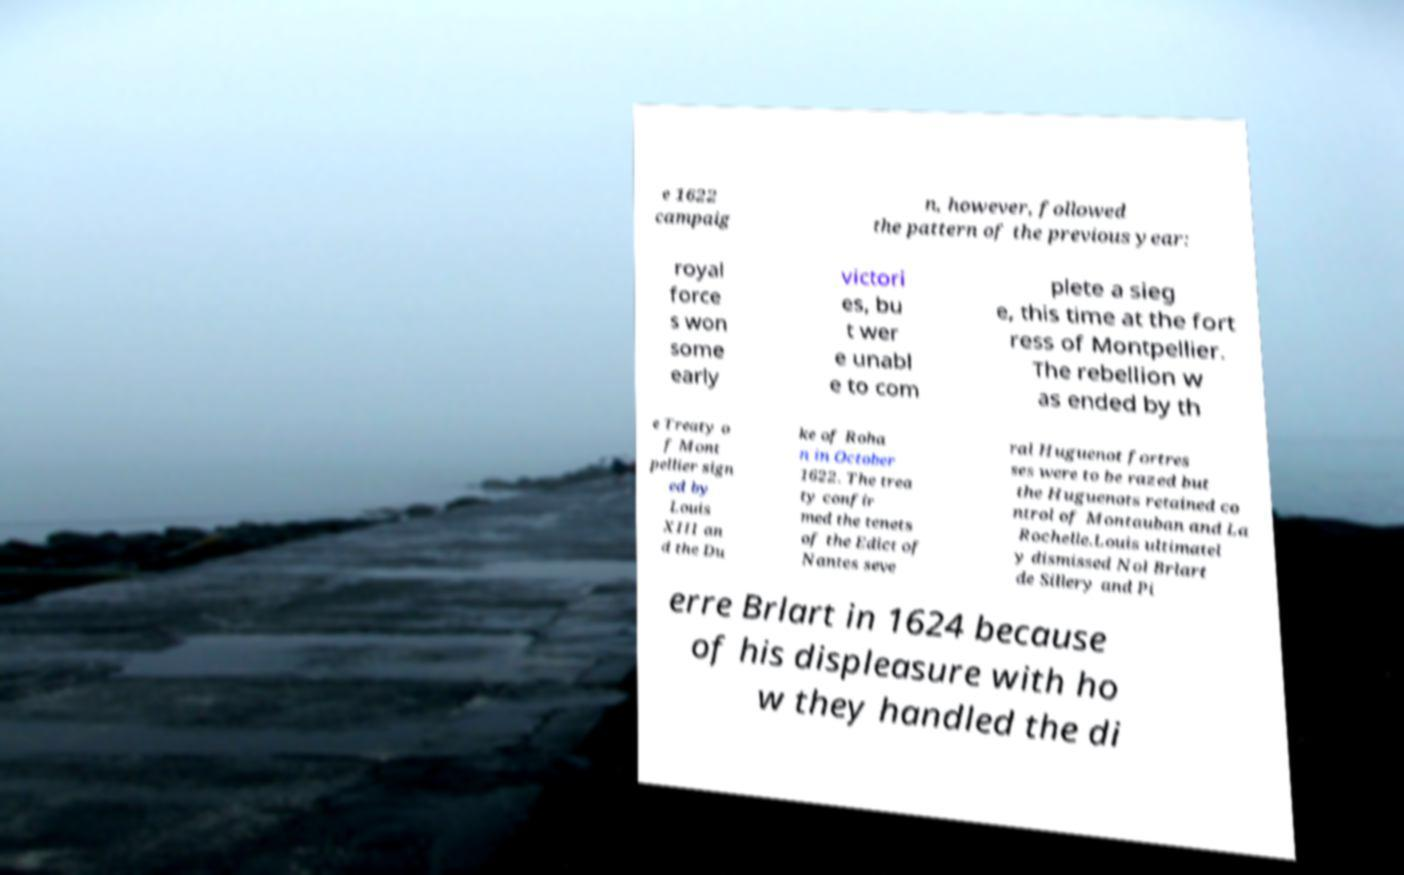I need the written content from this picture converted into text. Can you do that? e 1622 campaig n, however, followed the pattern of the previous year: royal force s won some early victori es, bu t wer e unabl e to com plete a sieg e, this time at the fort ress of Montpellier. The rebellion w as ended by th e Treaty o f Mont pellier sign ed by Louis XIII an d the Du ke of Roha n in October 1622. The trea ty confir med the tenets of the Edict of Nantes seve ral Huguenot fortres ses were to be razed but the Huguenots retained co ntrol of Montauban and La Rochelle.Louis ultimatel y dismissed Nol Brlart de Sillery and Pi erre Brlart in 1624 because of his displeasure with ho w they handled the di 